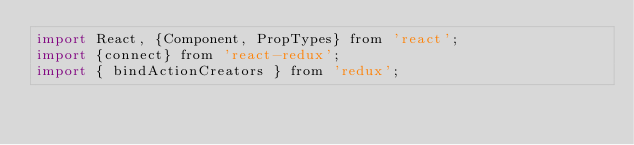Convert code to text. <code><loc_0><loc_0><loc_500><loc_500><_JavaScript_>import React, {Component, PropTypes} from 'react';
import {connect} from 'react-redux';
import { bindActionCreators } from 'redux';</code> 